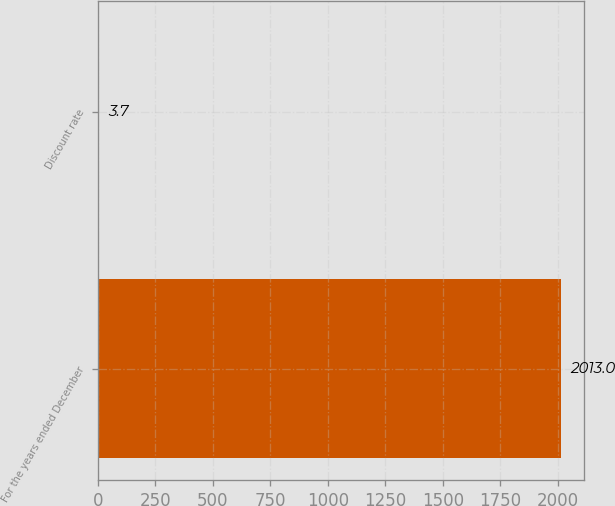Convert chart. <chart><loc_0><loc_0><loc_500><loc_500><bar_chart><fcel>For the years ended December<fcel>Discount rate<nl><fcel>2013<fcel>3.7<nl></chart> 